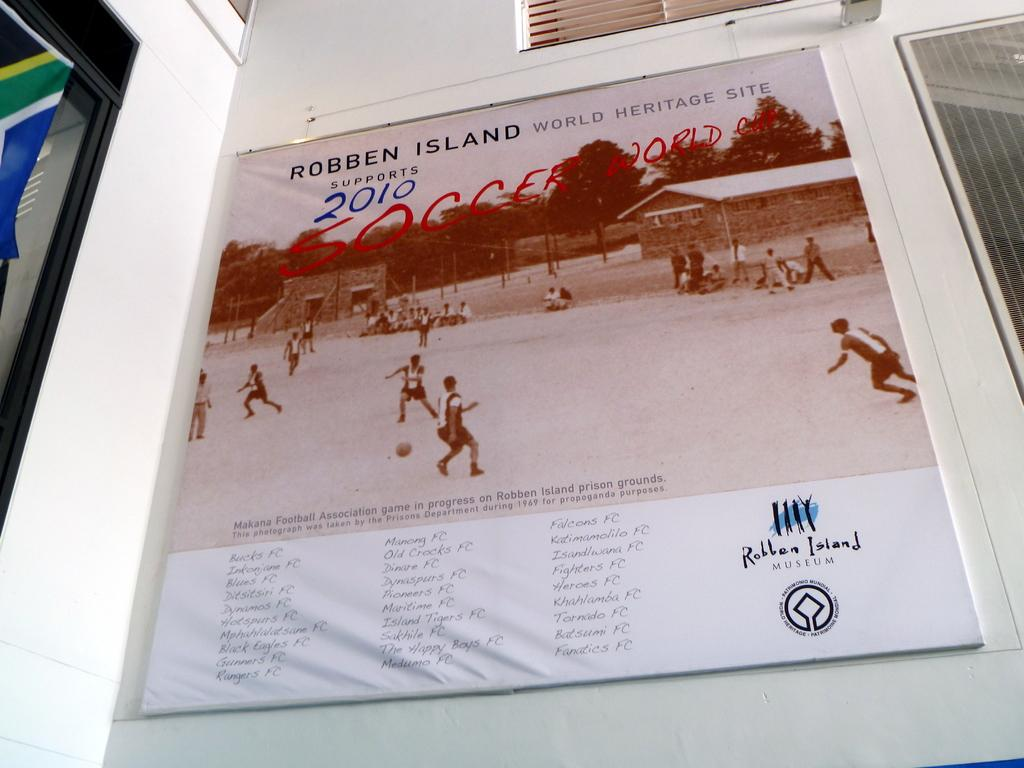What is on the wall in the image? There is a board on the wall in the image. What can be seen on the board? The board has text on it and a picture of people playing football. Where is the flag located in the image? There appears to be a flag on the left side of the image. What type of soap is being used by the carpenter in the image? There is no carpenter or soap present in the image. What type of home is depicted in the image? The image does not show a home; it features a board with text and a picture of people playing football. 